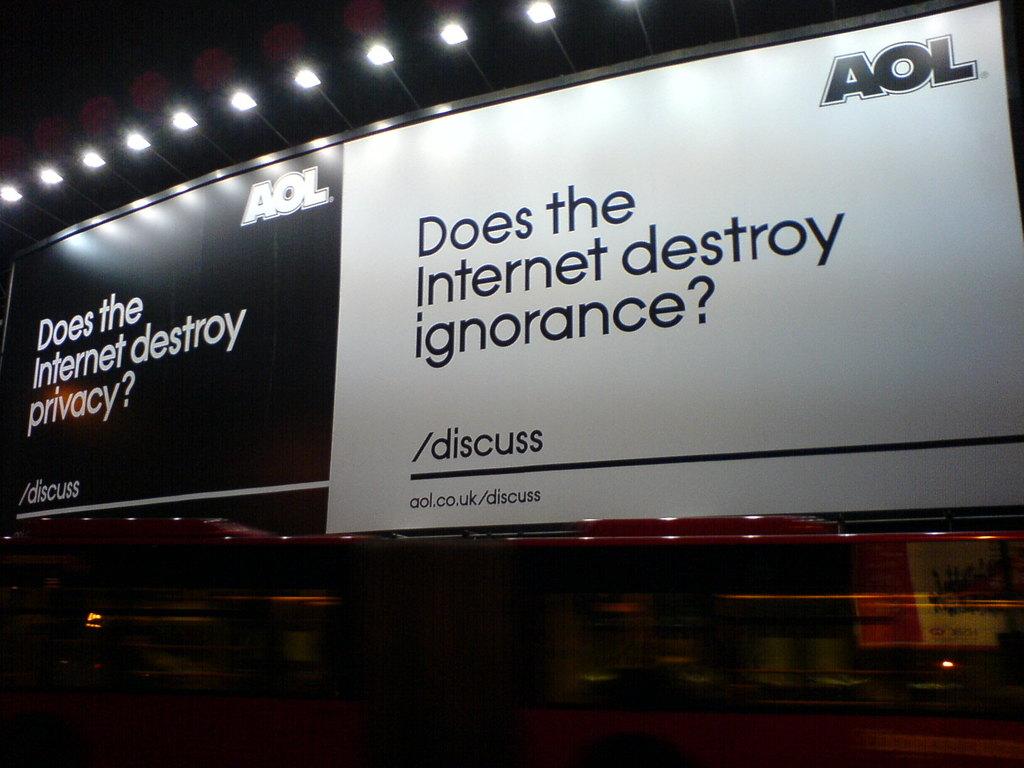What company sponsers this ad?
Your answer should be compact. Aol. 